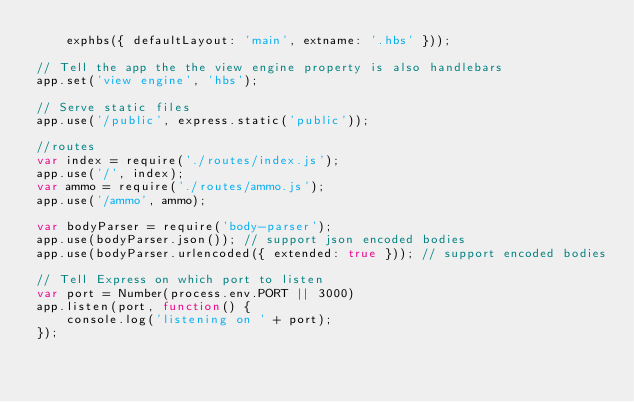<code> <loc_0><loc_0><loc_500><loc_500><_JavaScript_>    exphbs({ defaultLayout: 'main', extname: '.hbs' }));

// Tell the app the the view engine property is also handlebars
app.set('view engine', 'hbs');

// Serve static files
app.use('/public', express.static('public'));

//routes
var index = require('./routes/index.js');
app.use('/', index);
var ammo = require('./routes/ammo.js');
app.use('/ammo', ammo);

var bodyParser = require('body-parser');
app.use(bodyParser.json()); // support json encoded bodies
app.use(bodyParser.urlencoded({ extended: true })); // support encoded bodies

// Tell Express on which port to listen
var port = Number(process.env.PORT || 3000)
app.listen(port, function() {
    console.log('listening on ' + port);
});</code> 